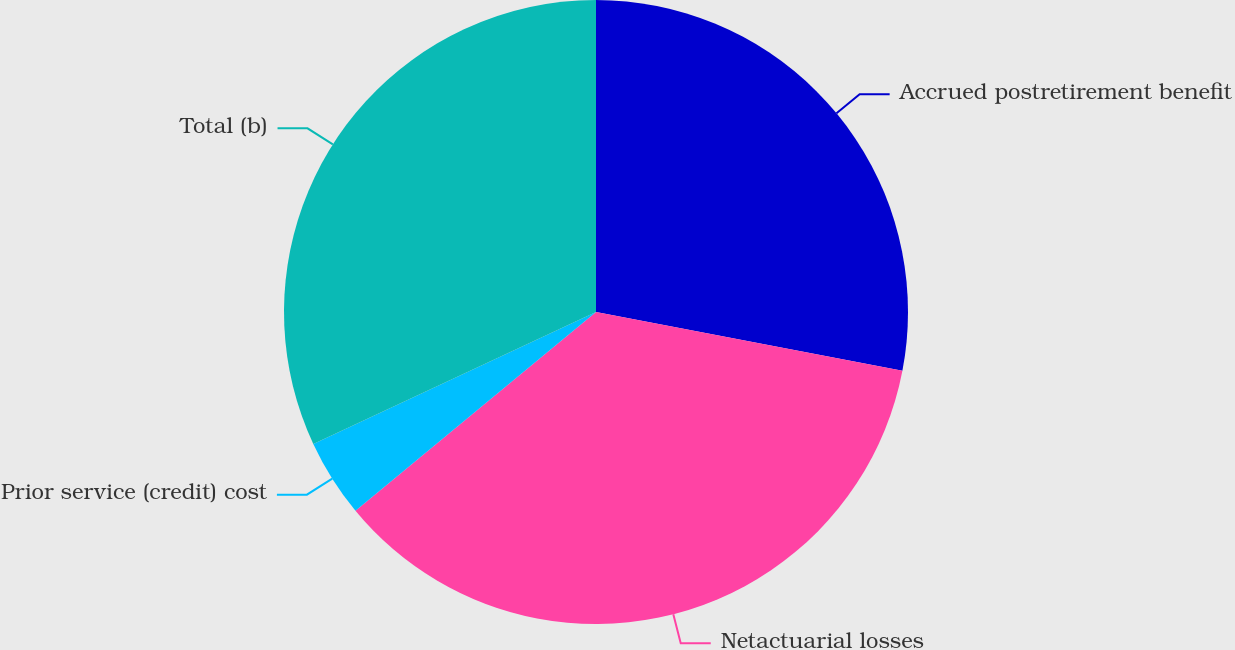<chart> <loc_0><loc_0><loc_500><loc_500><pie_chart><fcel>Accrued postretirement benefit<fcel>Netactuarial losses<fcel>Prior service (credit) cost<fcel>Total (b)<nl><fcel>28.02%<fcel>35.99%<fcel>4.04%<fcel>31.95%<nl></chart> 